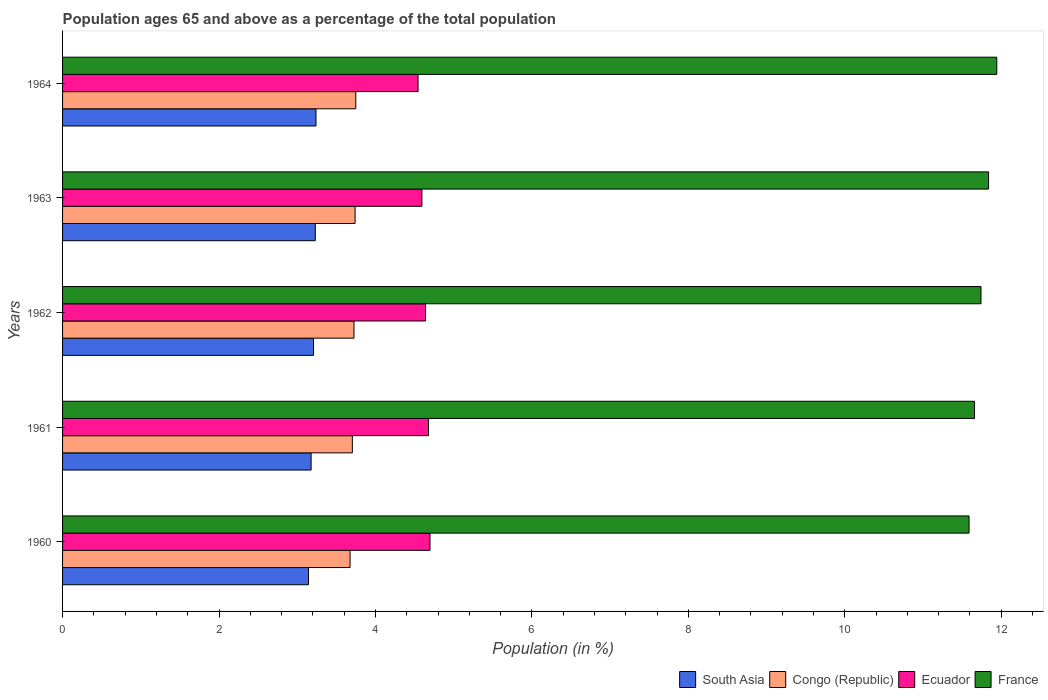How many different coloured bars are there?
Provide a short and direct response. 4. How many bars are there on the 3rd tick from the top?
Make the answer very short. 4. What is the percentage of the population ages 65 and above in South Asia in 1961?
Provide a succinct answer. 3.18. Across all years, what is the maximum percentage of the population ages 65 and above in Congo (Republic)?
Ensure brevity in your answer.  3.75. Across all years, what is the minimum percentage of the population ages 65 and above in France?
Your answer should be compact. 11.59. In which year was the percentage of the population ages 65 and above in France maximum?
Your response must be concise. 1964. In which year was the percentage of the population ages 65 and above in Ecuador minimum?
Provide a succinct answer. 1964. What is the total percentage of the population ages 65 and above in France in the graph?
Your response must be concise. 58.77. What is the difference between the percentage of the population ages 65 and above in Ecuador in 1962 and that in 1963?
Provide a short and direct response. 0.05. What is the difference between the percentage of the population ages 65 and above in South Asia in 1962 and the percentage of the population ages 65 and above in Ecuador in 1960?
Give a very brief answer. -1.49. What is the average percentage of the population ages 65 and above in South Asia per year?
Make the answer very short. 3.2. In the year 1960, what is the difference between the percentage of the population ages 65 and above in South Asia and percentage of the population ages 65 and above in Congo (Republic)?
Your response must be concise. -0.53. What is the ratio of the percentage of the population ages 65 and above in Ecuador in 1962 to that in 1964?
Provide a succinct answer. 1.02. Is the percentage of the population ages 65 and above in Congo (Republic) in 1961 less than that in 1964?
Make the answer very short. Yes. What is the difference between the highest and the second highest percentage of the population ages 65 and above in Ecuador?
Offer a very short reply. 0.02. What is the difference between the highest and the lowest percentage of the population ages 65 and above in Ecuador?
Make the answer very short. 0.15. Is it the case that in every year, the sum of the percentage of the population ages 65 and above in South Asia and percentage of the population ages 65 and above in Congo (Republic) is greater than the sum of percentage of the population ages 65 and above in France and percentage of the population ages 65 and above in Ecuador?
Give a very brief answer. No. What does the 3rd bar from the top in 1960 represents?
Offer a very short reply. Congo (Republic). Is it the case that in every year, the sum of the percentage of the population ages 65 and above in Congo (Republic) and percentage of the population ages 65 and above in Ecuador is greater than the percentage of the population ages 65 and above in South Asia?
Offer a terse response. Yes. Are all the bars in the graph horizontal?
Your answer should be compact. Yes. How many years are there in the graph?
Provide a short and direct response. 5. What is the difference between two consecutive major ticks on the X-axis?
Provide a short and direct response. 2. How many legend labels are there?
Keep it short and to the point. 4. What is the title of the graph?
Your response must be concise. Population ages 65 and above as a percentage of the total population. What is the Population (in %) in South Asia in 1960?
Your response must be concise. 3.14. What is the Population (in %) in Congo (Republic) in 1960?
Offer a very short reply. 3.68. What is the Population (in %) of Ecuador in 1960?
Keep it short and to the point. 4.7. What is the Population (in %) in France in 1960?
Give a very brief answer. 11.59. What is the Population (in %) of South Asia in 1961?
Your response must be concise. 3.18. What is the Population (in %) in Congo (Republic) in 1961?
Make the answer very short. 3.7. What is the Population (in %) of Ecuador in 1961?
Your answer should be very brief. 4.68. What is the Population (in %) of France in 1961?
Your answer should be compact. 11.66. What is the Population (in %) of South Asia in 1962?
Your response must be concise. 3.21. What is the Population (in %) in Congo (Republic) in 1962?
Offer a very short reply. 3.73. What is the Population (in %) in Ecuador in 1962?
Keep it short and to the point. 4.64. What is the Population (in %) of France in 1962?
Make the answer very short. 11.74. What is the Population (in %) in South Asia in 1963?
Your answer should be very brief. 3.23. What is the Population (in %) of Congo (Republic) in 1963?
Provide a succinct answer. 3.74. What is the Population (in %) in Ecuador in 1963?
Your answer should be very brief. 4.59. What is the Population (in %) of France in 1963?
Make the answer very short. 11.84. What is the Population (in %) of South Asia in 1964?
Give a very brief answer. 3.24. What is the Population (in %) in Congo (Republic) in 1964?
Give a very brief answer. 3.75. What is the Population (in %) in Ecuador in 1964?
Provide a succinct answer. 4.54. What is the Population (in %) in France in 1964?
Your answer should be very brief. 11.94. Across all years, what is the maximum Population (in %) of South Asia?
Keep it short and to the point. 3.24. Across all years, what is the maximum Population (in %) in Congo (Republic)?
Keep it short and to the point. 3.75. Across all years, what is the maximum Population (in %) in Ecuador?
Offer a very short reply. 4.7. Across all years, what is the maximum Population (in %) in France?
Ensure brevity in your answer.  11.94. Across all years, what is the minimum Population (in %) of South Asia?
Make the answer very short. 3.14. Across all years, what is the minimum Population (in %) of Congo (Republic)?
Provide a short and direct response. 3.68. Across all years, what is the minimum Population (in %) in Ecuador?
Your response must be concise. 4.54. Across all years, what is the minimum Population (in %) in France?
Ensure brevity in your answer.  11.59. What is the total Population (in %) of South Asia in the graph?
Provide a succinct answer. 16. What is the total Population (in %) in Congo (Republic) in the graph?
Offer a very short reply. 18.59. What is the total Population (in %) of Ecuador in the graph?
Your response must be concise. 23.15. What is the total Population (in %) in France in the graph?
Your response must be concise. 58.77. What is the difference between the Population (in %) in South Asia in 1960 and that in 1961?
Keep it short and to the point. -0.03. What is the difference between the Population (in %) in Congo (Republic) in 1960 and that in 1961?
Your response must be concise. -0.03. What is the difference between the Population (in %) of Ecuador in 1960 and that in 1961?
Provide a succinct answer. 0.02. What is the difference between the Population (in %) in France in 1960 and that in 1961?
Your response must be concise. -0.07. What is the difference between the Population (in %) of South Asia in 1960 and that in 1962?
Your answer should be compact. -0.06. What is the difference between the Population (in %) in Congo (Republic) in 1960 and that in 1962?
Provide a short and direct response. -0.05. What is the difference between the Population (in %) in Ecuador in 1960 and that in 1962?
Keep it short and to the point. 0.06. What is the difference between the Population (in %) of France in 1960 and that in 1962?
Offer a terse response. -0.15. What is the difference between the Population (in %) in South Asia in 1960 and that in 1963?
Your answer should be compact. -0.09. What is the difference between the Population (in %) of Congo (Republic) in 1960 and that in 1963?
Make the answer very short. -0.06. What is the difference between the Population (in %) in Ecuador in 1960 and that in 1963?
Provide a succinct answer. 0.1. What is the difference between the Population (in %) in France in 1960 and that in 1963?
Your answer should be compact. -0.25. What is the difference between the Population (in %) of South Asia in 1960 and that in 1964?
Offer a terse response. -0.1. What is the difference between the Population (in %) in Congo (Republic) in 1960 and that in 1964?
Offer a terse response. -0.07. What is the difference between the Population (in %) in Ecuador in 1960 and that in 1964?
Your response must be concise. 0.15. What is the difference between the Population (in %) of France in 1960 and that in 1964?
Ensure brevity in your answer.  -0.35. What is the difference between the Population (in %) in South Asia in 1961 and that in 1962?
Your response must be concise. -0.03. What is the difference between the Population (in %) of Congo (Republic) in 1961 and that in 1962?
Your answer should be very brief. -0.02. What is the difference between the Population (in %) of Ecuador in 1961 and that in 1962?
Keep it short and to the point. 0.04. What is the difference between the Population (in %) in France in 1961 and that in 1962?
Keep it short and to the point. -0.08. What is the difference between the Population (in %) of South Asia in 1961 and that in 1963?
Provide a succinct answer. -0.05. What is the difference between the Population (in %) in Congo (Republic) in 1961 and that in 1963?
Your answer should be compact. -0.04. What is the difference between the Population (in %) in Ecuador in 1961 and that in 1963?
Give a very brief answer. 0.08. What is the difference between the Population (in %) in France in 1961 and that in 1963?
Provide a short and direct response. -0.18. What is the difference between the Population (in %) of South Asia in 1961 and that in 1964?
Make the answer very short. -0.06. What is the difference between the Population (in %) in Congo (Republic) in 1961 and that in 1964?
Ensure brevity in your answer.  -0.04. What is the difference between the Population (in %) in Ecuador in 1961 and that in 1964?
Your response must be concise. 0.13. What is the difference between the Population (in %) in France in 1961 and that in 1964?
Offer a terse response. -0.28. What is the difference between the Population (in %) of South Asia in 1962 and that in 1963?
Your answer should be very brief. -0.02. What is the difference between the Population (in %) in Congo (Republic) in 1962 and that in 1963?
Ensure brevity in your answer.  -0.01. What is the difference between the Population (in %) of Ecuador in 1962 and that in 1963?
Ensure brevity in your answer.  0.05. What is the difference between the Population (in %) in France in 1962 and that in 1963?
Give a very brief answer. -0.1. What is the difference between the Population (in %) in South Asia in 1962 and that in 1964?
Your answer should be compact. -0.03. What is the difference between the Population (in %) in Congo (Republic) in 1962 and that in 1964?
Your response must be concise. -0.02. What is the difference between the Population (in %) of Ecuador in 1962 and that in 1964?
Keep it short and to the point. 0.1. What is the difference between the Population (in %) in France in 1962 and that in 1964?
Your answer should be compact. -0.2. What is the difference between the Population (in %) of South Asia in 1963 and that in 1964?
Offer a very short reply. -0.01. What is the difference between the Population (in %) of Congo (Republic) in 1963 and that in 1964?
Provide a succinct answer. -0.01. What is the difference between the Population (in %) of Ecuador in 1963 and that in 1964?
Provide a succinct answer. 0.05. What is the difference between the Population (in %) in France in 1963 and that in 1964?
Ensure brevity in your answer.  -0.11. What is the difference between the Population (in %) in South Asia in 1960 and the Population (in %) in Congo (Republic) in 1961?
Your response must be concise. -0.56. What is the difference between the Population (in %) in South Asia in 1960 and the Population (in %) in Ecuador in 1961?
Give a very brief answer. -1.53. What is the difference between the Population (in %) in South Asia in 1960 and the Population (in %) in France in 1961?
Offer a terse response. -8.51. What is the difference between the Population (in %) of Congo (Republic) in 1960 and the Population (in %) of Ecuador in 1961?
Offer a terse response. -1. What is the difference between the Population (in %) in Congo (Republic) in 1960 and the Population (in %) in France in 1961?
Make the answer very short. -7.98. What is the difference between the Population (in %) of Ecuador in 1960 and the Population (in %) of France in 1961?
Provide a short and direct response. -6.96. What is the difference between the Population (in %) in South Asia in 1960 and the Population (in %) in Congo (Republic) in 1962?
Provide a succinct answer. -0.58. What is the difference between the Population (in %) in South Asia in 1960 and the Population (in %) in Ecuador in 1962?
Offer a very short reply. -1.5. What is the difference between the Population (in %) in South Asia in 1960 and the Population (in %) in France in 1962?
Make the answer very short. -8.6. What is the difference between the Population (in %) in Congo (Republic) in 1960 and the Population (in %) in Ecuador in 1962?
Provide a short and direct response. -0.96. What is the difference between the Population (in %) in Congo (Republic) in 1960 and the Population (in %) in France in 1962?
Offer a terse response. -8.07. What is the difference between the Population (in %) in Ecuador in 1960 and the Population (in %) in France in 1962?
Keep it short and to the point. -7.04. What is the difference between the Population (in %) of South Asia in 1960 and the Population (in %) of Congo (Republic) in 1963?
Provide a succinct answer. -0.6. What is the difference between the Population (in %) in South Asia in 1960 and the Population (in %) in Ecuador in 1963?
Your answer should be very brief. -1.45. What is the difference between the Population (in %) in South Asia in 1960 and the Population (in %) in France in 1963?
Provide a succinct answer. -8.69. What is the difference between the Population (in %) in Congo (Republic) in 1960 and the Population (in %) in Ecuador in 1963?
Give a very brief answer. -0.92. What is the difference between the Population (in %) in Congo (Republic) in 1960 and the Population (in %) in France in 1963?
Ensure brevity in your answer.  -8.16. What is the difference between the Population (in %) of Ecuador in 1960 and the Population (in %) of France in 1963?
Make the answer very short. -7.14. What is the difference between the Population (in %) in South Asia in 1960 and the Population (in %) in Congo (Republic) in 1964?
Give a very brief answer. -0.6. What is the difference between the Population (in %) of South Asia in 1960 and the Population (in %) of Ecuador in 1964?
Your answer should be very brief. -1.4. What is the difference between the Population (in %) in South Asia in 1960 and the Population (in %) in France in 1964?
Offer a terse response. -8.8. What is the difference between the Population (in %) of Congo (Republic) in 1960 and the Population (in %) of Ecuador in 1964?
Your answer should be very brief. -0.87. What is the difference between the Population (in %) of Congo (Republic) in 1960 and the Population (in %) of France in 1964?
Your response must be concise. -8.27. What is the difference between the Population (in %) in Ecuador in 1960 and the Population (in %) in France in 1964?
Offer a terse response. -7.25. What is the difference between the Population (in %) in South Asia in 1961 and the Population (in %) in Congo (Republic) in 1962?
Your answer should be compact. -0.55. What is the difference between the Population (in %) of South Asia in 1961 and the Population (in %) of Ecuador in 1962?
Offer a terse response. -1.46. What is the difference between the Population (in %) of South Asia in 1961 and the Population (in %) of France in 1962?
Your response must be concise. -8.56. What is the difference between the Population (in %) of Congo (Republic) in 1961 and the Population (in %) of Ecuador in 1962?
Provide a short and direct response. -0.94. What is the difference between the Population (in %) of Congo (Republic) in 1961 and the Population (in %) of France in 1962?
Your answer should be compact. -8.04. What is the difference between the Population (in %) in Ecuador in 1961 and the Population (in %) in France in 1962?
Offer a terse response. -7.06. What is the difference between the Population (in %) of South Asia in 1961 and the Population (in %) of Congo (Republic) in 1963?
Offer a very short reply. -0.56. What is the difference between the Population (in %) of South Asia in 1961 and the Population (in %) of Ecuador in 1963?
Your response must be concise. -1.42. What is the difference between the Population (in %) of South Asia in 1961 and the Population (in %) of France in 1963?
Offer a very short reply. -8.66. What is the difference between the Population (in %) in Congo (Republic) in 1961 and the Population (in %) in Ecuador in 1963?
Provide a short and direct response. -0.89. What is the difference between the Population (in %) in Congo (Republic) in 1961 and the Population (in %) in France in 1963?
Your answer should be compact. -8.13. What is the difference between the Population (in %) in Ecuador in 1961 and the Population (in %) in France in 1963?
Your answer should be very brief. -7.16. What is the difference between the Population (in %) of South Asia in 1961 and the Population (in %) of Congo (Republic) in 1964?
Make the answer very short. -0.57. What is the difference between the Population (in %) of South Asia in 1961 and the Population (in %) of Ecuador in 1964?
Offer a terse response. -1.37. What is the difference between the Population (in %) in South Asia in 1961 and the Population (in %) in France in 1964?
Make the answer very short. -8.77. What is the difference between the Population (in %) in Congo (Republic) in 1961 and the Population (in %) in Ecuador in 1964?
Your answer should be compact. -0.84. What is the difference between the Population (in %) in Congo (Republic) in 1961 and the Population (in %) in France in 1964?
Provide a succinct answer. -8.24. What is the difference between the Population (in %) of Ecuador in 1961 and the Population (in %) of France in 1964?
Keep it short and to the point. -7.27. What is the difference between the Population (in %) in South Asia in 1962 and the Population (in %) in Congo (Republic) in 1963?
Keep it short and to the point. -0.53. What is the difference between the Population (in %) of South Asia in 1962 and the Population (in %) of Ecuador in 1963?
Your answer should be very brief. -1.39. What is the difference between the Population (in %) in South Asia in 1962 and the Population (in %) in France in 1963?
Ensure brevity in your answer.  -8.63. What is the difference between the Population (in %) in Congo (Republic) in 1962 and the Population (in %) in Ecuador in 1963?
Ensure brevity in your answer.  -0.87. What is the difference between the Population (in %) of Congo (Republic) in 1962 and the Population (in %) of France in 1963?
Make the answer very short. -8.11. What is the difference between the Population (in %) in Ecuador in 1962 and the Population (in %) in France in 1963?
Provide a short and direct response. -7.2. What is the difference between the Population (in %) of South Asia in 1962 and the Population (in %) of Congo (Republic) in 1964?
Your answer should be very brief. -0.54. What is the difference between the Population (in %) in South Asia in 1962 and the Population (in %) in Ecuador in 1964?
Offer a very short reply. -1.34. What is the difference between the Population (in %) of South Asia in 1962 and the Population (in %) of France in 1964?
Provide a short and direct response. -8.73. What is the difference between the Population (in %) in Congo (Republic) in 1962 and the Population (in %) in Ecuador in 1964?
Offer a very short reply. -0.82. What is the difference between the Population (in %) of Congo (Republic) in 1962 and the Population (in %) of France in 1964?
Your answer should be compact. -8.22. What is the difference between the Population (in %) in Ecuador in 1962 and the Population (in %) in France in 1964?
Your answer should be compact. -7.3. What is the difference between the Population (in %) in South Asia in 1963 and the Population (in %) in Congo (Republic) in 1964?
Provide a succinct answer. -0.52. What is the difference between the Population (in %) of South Asia in 1963 and the Population (in %) of Ecuador in 1964?
Your answer should be compact. -1.31. What is the difference between the Population (in %) in South Asia in 1963 and the Population (in %) in France in 1964?
Your response must be concise. -8.71. What is the difference between the Population (in %) in Congo (Republic) in 1963 and the Population (in %) in Ecuador in 1964?
Offer a very short reply. -0.81. What is the difference between the Population (in %) of Congo (Republic) in 1963 and the Population (in %) of France in 1964?
Keep it short and to the point. -8.2. What is the difference between the Population (in %) of Ecuador in 1963 and the Population (in %) of France in 1964?
Provide a succinct answer. -7.35. What is the average Population (in %) of South Asia per year?
Offer a terse response. 3.2. What is the average Population (in %) in Congo (Republic) per year?
Your answer should be compact. 3.72. What is the average Population (in %) of Ecuador per year?
Provide a short and direct response. 4.63. What is the average Population (in %) of France per year?
Offer a very short reply. 11.75. In the year 1960, what is the difference between the Population (in %) in South Asia and Population (in %) in Congo (Republic)?
Your answer should be compact. -0.53. In the year 1960, what is the difference between the Population (in %) of South Asia and Population (in %) of Ecuador?
Make the answer very short. -1.55. In the year 1960, what is the difference between the Population (in %) of South Asia and Population (in %) of France?
Your response must be concise. -8.44. In the year 1960, what is the difference between the Population (in %) in Congo (Republic) and Population (in %) in Ecuador?
Your answer should be very brief. -1.02. In the year 1960, what is the difference between the Population (in %) in Congo (Republic) and Population (in %) in France?
Offer a very short reply. -7.91. In the year 1960, what is the difference between the Population (in %) of Ecuador and Population (in %) of France?
Offer a terse response. -6.89. In the year 1961, what is the difference between the Population (in %) in South Asia and Population (in %) in Congo (Republic)?
Give a very brief answer. -0.53. In the year 1961, what is the difference between the Population (in %) in South Asia and Population (in %) in France?
Your response must be concise. -8.48. In the year 1961, what is the difference between the Population (in %) in Congo (Republic) and Population (in %) in Ecuador?
Keep it short and to the point. -0.97. In the year 1961, what is the difference between the Population (in %) in Congo (Republic) and Population (in %) in France?
Your response must be concise. -7.95. In the year 1961, what is the difference between the Population (in %) of Ecuador and Population (in %) of France?
Keep it short and to the point. -6.98. In the year 1962, what is the difference between the Population (in %) of South Asia and Population (in %) of Congo (Republic)?
Your answer should be very brief. -0.52. In the year 1962, what is the difference between the Population (in %) in South Asia and Population (in %) in Ecuador?
Provide a short and direct response. -1.43. In the year 1962, what is the difference between the Population (in %) in South Asia and Population (in %) in France?
Provide a succinct answer. -8.53. In the year 1962, what is the difference between the Population (in %) of Congo (Republic) and Population (in %) of Ecuador?
Provide a short and direct response. -0.92. In the year 1962, what is the difference between the Population (in %) in Congo (Republic) and Population (in %) in France?
Offer a terse response. -8.02. In the year 1962, what is the difference between the Population (in %) in Ecuador and Population (in %) in France?
Ensure brevity in your answer.  -7.1. In the year 1963, what is the difference between the Population (in %) of South Asia and Population (in %) of Congo (Republic)?
Your answer should be compact. -0.51. In the year 1963, what is the difference between the Population (in %) in South Asia and Population (in %) in Ecuador?
Provide a succinct answer. -1.36. In the year 1963, what is the difference between the Population (in %) in South Asia and Population (in %) in France?
Offer a very short reply. -8.61. In the year 1963, what is the difference between the Population (in %) of Congo (Republic) and Population (in %) of Ecuador?
Give a very brief answer. -0.85. In the year 1963, what is the difference between the Population (in %) in Congo (Republic) and Population (in %) in France?
Provide a succinct answer. -8.1. In the year 1963, what is the difference between the Population (in %) of Ecuador and Population (in %) of France?
Provide a succinct answer. -7.24. In the year 1964, what is the difference between the Population (in %) of South Asia and Population (in %) of Congo (Republic)?
Your answer should be compact. -0.51. In the year 1964, what is the difference between the Population (in %) of South Asia and Population (in %) of Ecuador?
Keep it short and to the point. -1.3. In the year 1964, what is the difference between the Population (in %) of South Asia and Population (in %) of France?
Ensure brevity in your answer.  -8.7. In the year 1964, what is the difference between the Population (in %) in Congo (Republic) and Population (in %) in Ecuador?
Your answer should be very brief. -0.8. In the year 1964, what is the difference between the Population (in %) in Congo (Republic) and Population (in %) in France?
Keep it short and to the point. -8.19. In the year 1964, what is the difference between the Population (in %) in Ecuador and Population (in %) in France?
Make the answer very short. -7.4. What is the ratio of the Population (in %) of France in 1960 to that in 1961?
Make the answer very short. 0.99. What is the ratio of the Population (in %) of Congo (Republic) in 1960 to that in 1962?
Offer a very short reply. 0.99. What is the ratio of the Population (in %) of Ecuador in 1960 to that in 1962?
Your answer should be compact. 1.01. What is the ratio of the Population (in %) in South Asia in 1960 to that in 1963?
Your answer should be compact. 0.97. What is the ratio of the Population (in %) in Congo (Republic) in 1960 to that in 1963?
Make the answer very short. 0.98. What is the ratio of the Population (in %) in Ecuador in 1960 to that in 1963?
Ensure brevity in your answer.  1.02. What is the ratio of the Population (in %) in France in 1960 to that in 1963?
Give a very brief answer. 0.98. What is the ratio of the Population (in %) in South Asia in 1960 to that in 1964?
Offer a very short reply. 0.97. What is the ratio of the Population (in %) in Congo (Republic) in 1960 to that in 1964?
Keep it short and to the point. 0.98. What is the ratio of the Population (in %) of Ecuador in 1960 to that in 1964?
Provide a succinct answer. 1.03. What is the ratio of the Population (in %) in France in 1960 to that in 1964?
Provide a succinct answer. 0.97. What is the ratio of the Population (in %) in South Asia in 1961 to that in 1962?
Provide a short and direct response. 0.99. What is the ratio of the Population (in %) in Congo (Republic) in 1961 to that in 1962?
Provide a short and direct response. 0.99. What is the ratio of the Population (in %) in Ecuador in 1961 to that in 1962?
Your answer should be compact. 1.01. What is the ratio of the Population (in %) in South Asia in 1961 to that in 1963?
Offer a very short reply. 0.98. What is the ratio of the Population (in %) of Congo (Republic) in 1961 to that in 1963?
Your response must be concise. 0.99. What is the ratio of the Population (in %) in Ecuador in 1961 to that in 1963?
Ensure brevity in your answer.  1.02. What is the ratio of the Population (in %) in France in 1961 to that in 1963?
Your answer should be compact. 0.98. What is the ratio of the Population (in %) in South Asia in 1961 to that in 1964?
Keep it short and to the point. 0.98. What is the ratio of the Population (in %) in Congo (Republic) in 1961 to that in 1964?
Keep it short and to the point. 0.99. What is the ratio of the Population (in %) of Ecuador in 1961 to that in 1964?
Your answer should be compact. 1.03. What is the ratio of the Population (in %) of France in 1961 to that in 1964?
Ensure brevity in your answer.  0.98. What is the ratio of the Population (in %) in South Asia in 1962 to that in 1963?
Offer a very short reply. 0.99. What is the ratio of the Population (in %) of Ecuador in 1962 to that in 1963?
Make the answer very short. 1.01. What is the ratio of the Population (in %) in South Asia in 1962 to that in 1964?
Your answer should be very brief. 0.99. What is the ratio of the Population (in %) of Ecuador in 1962 to that in 1964?
Keep it short and to the point. 1.02. What is the ratio of the Population (in %) of France in 1962 to that in 1964?
Give a very brief answer. 0.98. What is the ratio of the Population (in %) of South Asia in 1963 to that in 1964?
Give a very brief answer. 1. What is the ratio of the Population (in %) of Ecuador in 1963 to that in 1964?
Keep it short and to the point. 1.01. What is the ratio of the Population (in %) in France in 1963 to that in 1964?
Offer a terse response. 0.99. What is the difference between the highest and the second highest Population (in %) in South Asia?
Keep it short and to the point. 0.01. What is the difference between the highest and the second highest Population (in %) in Congo (Republic)?
Ensure brevity in your answer.  0.01. What is the difference between the highest and the second highest Population (in %) in Ecuador?
Ensure brevity in your answer.  0.02. What is the difference between the highest and the second highest Population (in %) in France?
Offer a very short reply. 0.11. What is the difference between the highest and the lowest Population (in %) of South Asia?
Offer a very short reply. 0.1. What is the difference between the highest and the lowest Population (in %) in Congo (Republic)?
Your answer should be very brief. 0.07. What is the difference between the highest and the lowest Population (in %) of Ecuador?
Provide a short and direct response. 0.15. What is the difference between the highest and the lowest Population (in %) of France?
Provide a succinct answer. 0.35. 